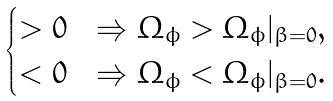<formula> <loc_0><loc_0><loc_500><loc_500>\begin{cases} > 0 & \Rightarrow \Omega _ { \phi } > \Omega _ { \phi } | _ { \beta = 0 } , \\ < 0 & \Rightarrow \Omega _ { \phi } < \Omega _ { \phi } | _ { \beta = 0 } . \end{cases}</formula> 